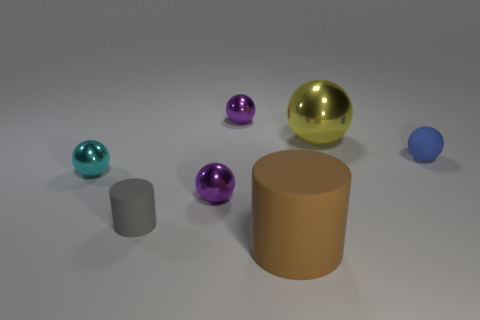What number of brown rubber things are the same shape as the yellow thing?
Make the answer very short. 0. Is the number of tiny purple things behind the tiny cyan sphere greater than the number of green rubber cubes?
Your response must be concise. Yes. What is the shape of the tiny metallic object that is both to the right of the tiny gray matte thing and in front of the big yellow metal sphere?
Your answer should be very brief. Sphere. Do the gray rubber thing and the blue matte sphere have the same size?
Give a very brief answer. Yes. What number of big objects are in front of the tiny blue rubber ball?
Make the answer very short. 1. Are there the same number of small blue balls on the right side of the tiny blue ball and shiny balls that are behind the big metallic object?
Your answer should be very brief. No. Does the rubber thing that is left of the brown object have the same shape as the brown object?
Keep it short and to the point. Yes. There is a cyan metal ball; is its size the same as the matte cylinder right of the small cylinder?
Provide a short and direct response. No. How many other things are there of the same color as the large cylinder?
Offer a very short reply. 0. Are there any big brown matte objects right of the large yellow thing?
Make the answer very short. No. 